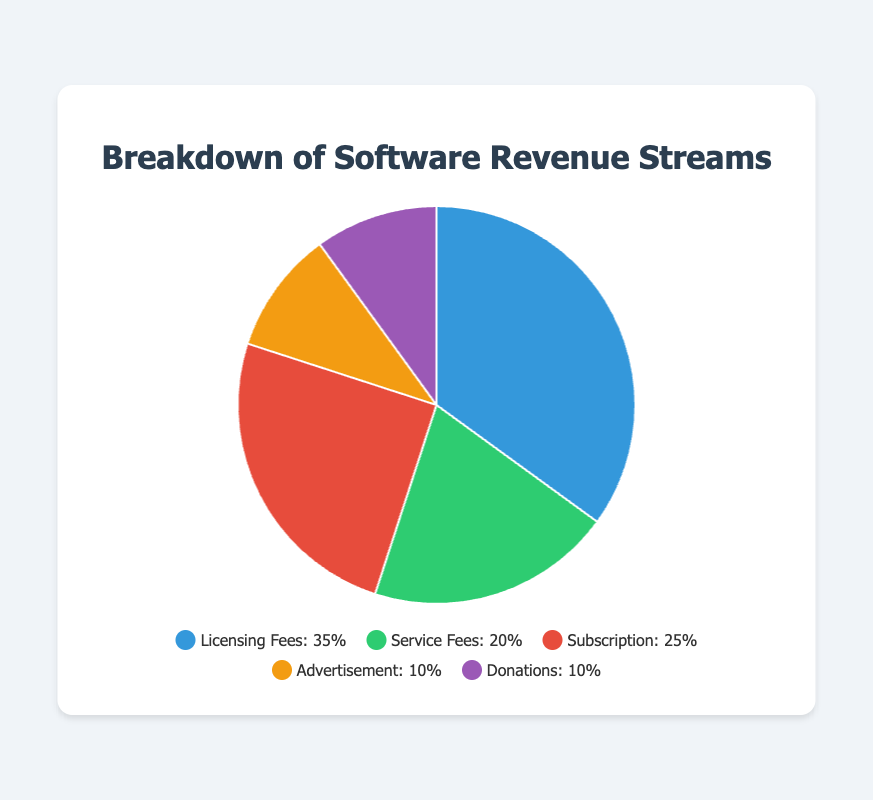Which revenue stream has the largest share? The revenue stream with the largest share in the pie chart is visually the largest segment. By looking at the plot, the "Licensing Fees" segment clearly occupies the largest area.
Answer: Licensing Fees What is the combined percentage of Advertisement and Donations revenue streams? The percentages for Advertisement and Donations in the pie chart are 10% each. Adding them up: 10% + 10% = 20%
Answer: 20% How does the share of Subscription revenue compare to the share of Service Fees? The Subscription segment (25%) is larger than the Service Fees segment (20%). Therefore, the Subscription revenue share is 5% greater than the Service Fees.
Answer: Subscription is 5% greater Which two revenue streams have the same percentage? By examining the pie chart, Advertisement and Donations each occupy the same segment size of 10%.
Answer: Advertisement and Donations What is the total percentage of revenue streams other than Licensing Fees? The "Licensing Fees" segment is 35%. The total revenue is 100%, thus, the remaining percentage is 100% - 35% = 65%.
Answer: 65% What are the respective colors for Service Fees and Donations in the pie chart? Service Fees is represented in green and Donations are shown in purple in the pie chart.
Answer: Green (Service Fees), Purple (Donations) Which revenue stream is visually represented in red in the pie chart? The red segment in the pie chart corresponds to the Subscription revenue stream.
Answer: Subscription What is the difference in percentage between the highest and lowest revenue streams? The highest revenue stream is Licensing Fees at 35%, and the lowest revenue streams are Advertisement and Donations at 10% each. The difference is 35% - 10% = 25%.
Answer: 25% What is the combined percentage for Licensing Fees and Subscription revenue streams? The pie chart shows Licensing Fees at 35% and Subscription at 25%. Adding them up: 35% + 25% = 60%
Answer: 60% 